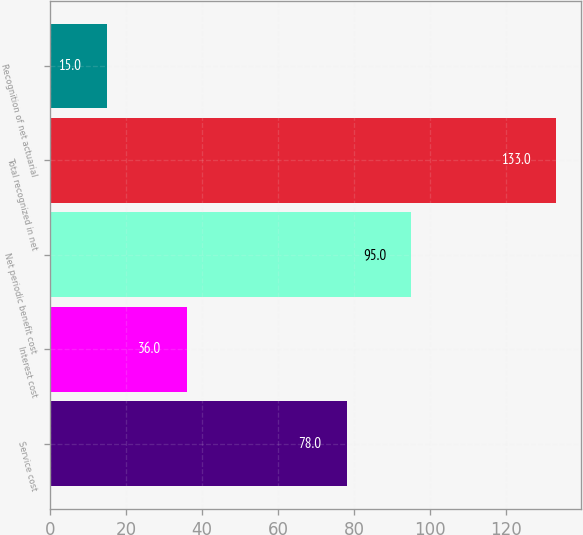Convert chart. <chart><loc_0><loc_0><loc_500><loc_500><bar_chart><fcel>Service cost<fcel>Interest cost<fcel>Net periodic benefit cost<fcel>Total recognized in net<fcel>Recognition of net actuarial<nl><fcel>78<fcel>36<fcel>95<fcel>133<fcel>15<nl></chart> 